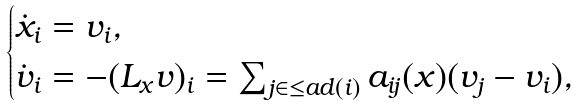<formula> <loc_0><loc_0><loc_500><loc_500>\begin{cases} \dot { x } _ { i } = v _ { i } , \\ \dot { v } _ { i } = - ( L _ { x } v ) _ { i } = \sum _ { j \in \leq a d ( i ) } a _ { i j } ( x ) ( v _ { j } - v _ { i } ) , \end{cases}</formula> 